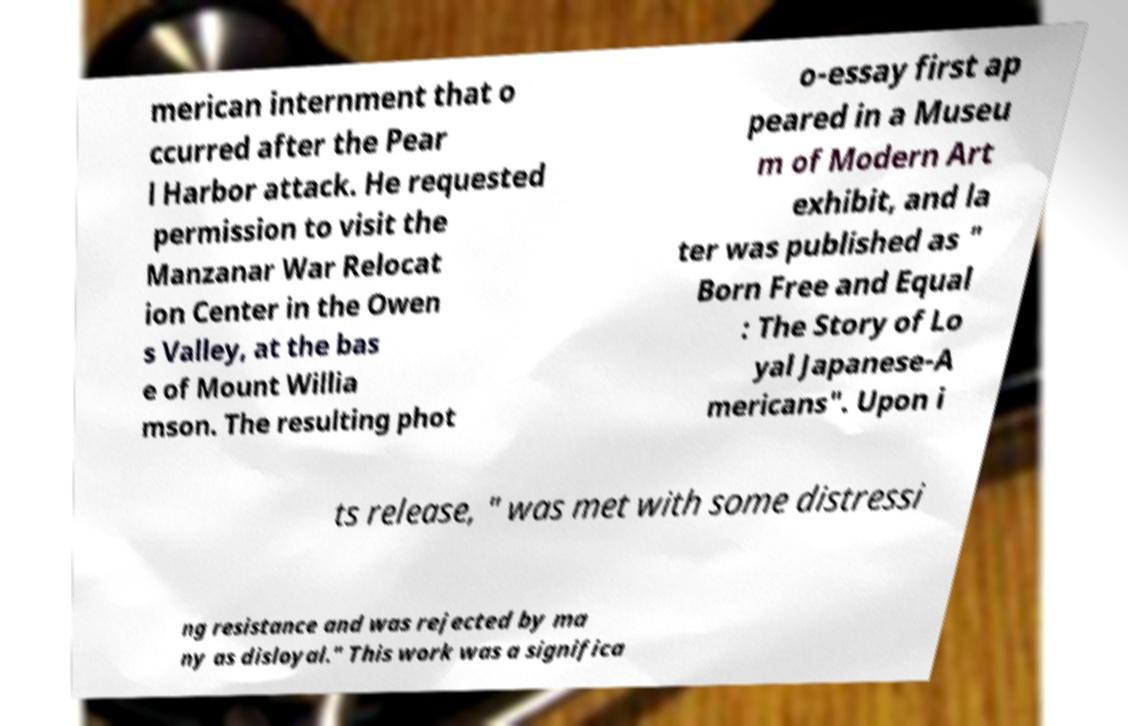Can you read and provide the text displayed in the image?This photo seems to have some interesting text. Can you extract and type it out for me? merican internment that o ccurred after the Pear l Harbor attack. He requested permission to visit the Manzanar War Relocat ion Center in the Owen s Valley, at the bas e of Mount Willia mson. The resulting phot o-essay first ap peared in a Museu m of Modern Art exhibit, and la ter was published as " Born Free and Equal : The Story of Lo yal Japanese-A mericans". Upon i ts release, " was met with some distressi ng resistance and was rejected by ma ny as disloyal." This work was a significa 